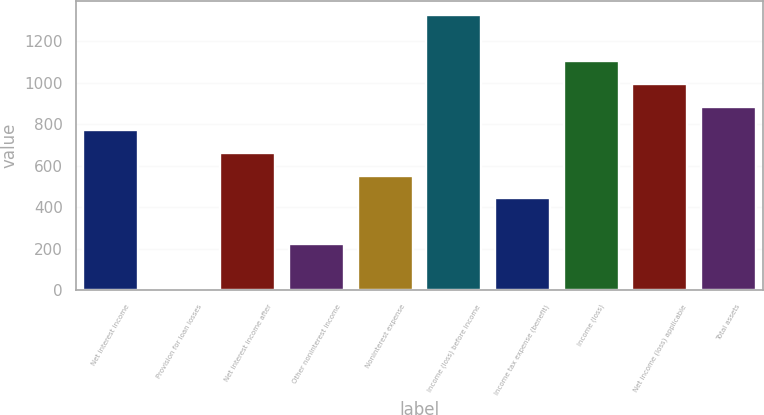Convert chart. <chart><loc_0><loc_0><loc_500><loc_500><bar_chart><fcel>Net interest income<fcel>Provision for loan losses<fcel>Net interest income after<fcel>Other noninterest income<fcel>Noninterest expense<fcel>Income (loss) before income<fcel>Income tax expense (benefit)<fcel>Income (loss)<fcel>Net income (loss) applicable<fcel>Total assets<nl><fcel>774.29<fcel>0.3<fcel>663.72<fcel>221.44<fcel>553.15<fcel>1327.14<fcel>442.58<fcel>1106<fcel>995.43<fcel>884.86<nl></chart> 